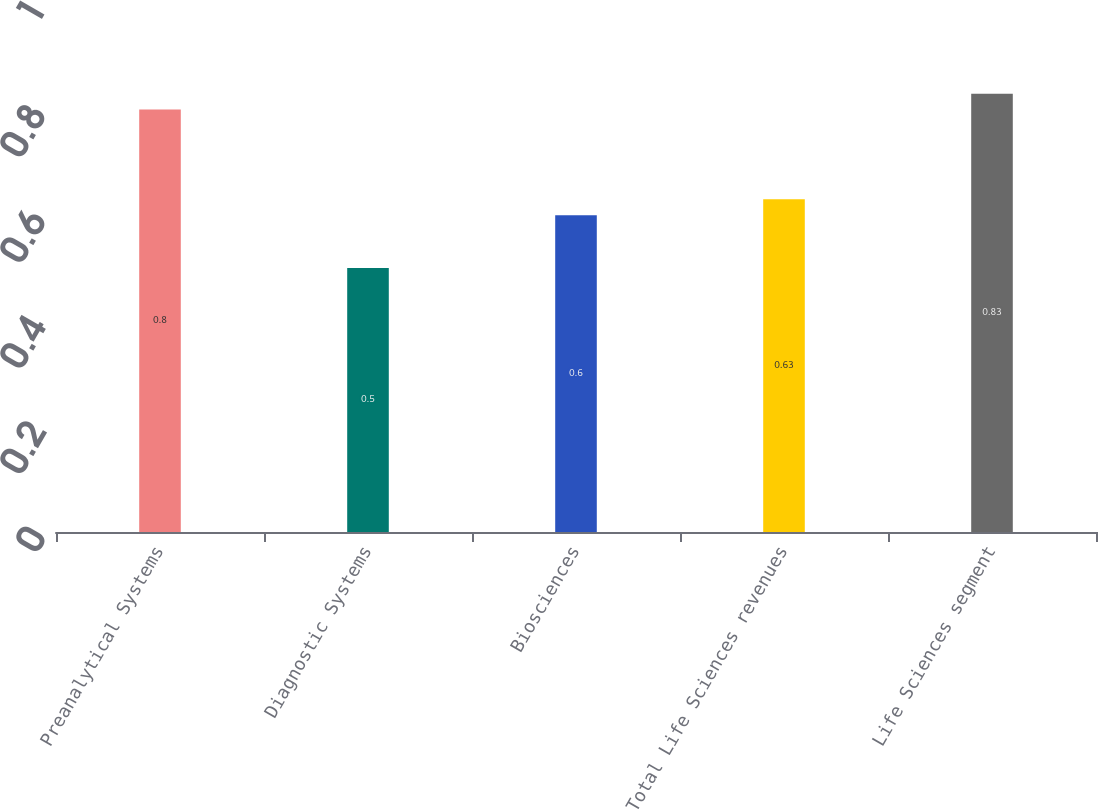Convert chart. <chart><loc_0><loc_0><loc_500><loc_500><bar_chart><fcel>Preanalytical Systems<fcel>Diagnostic Systems<fcel>Biosciences<fcel>Total Life Sciences revenues<fcel>Life Sciences segment<nl><fcel>0.8<fcel>0.5<fcel>0.6<fcel>0.63<fcel>0.83<nl></chart> 